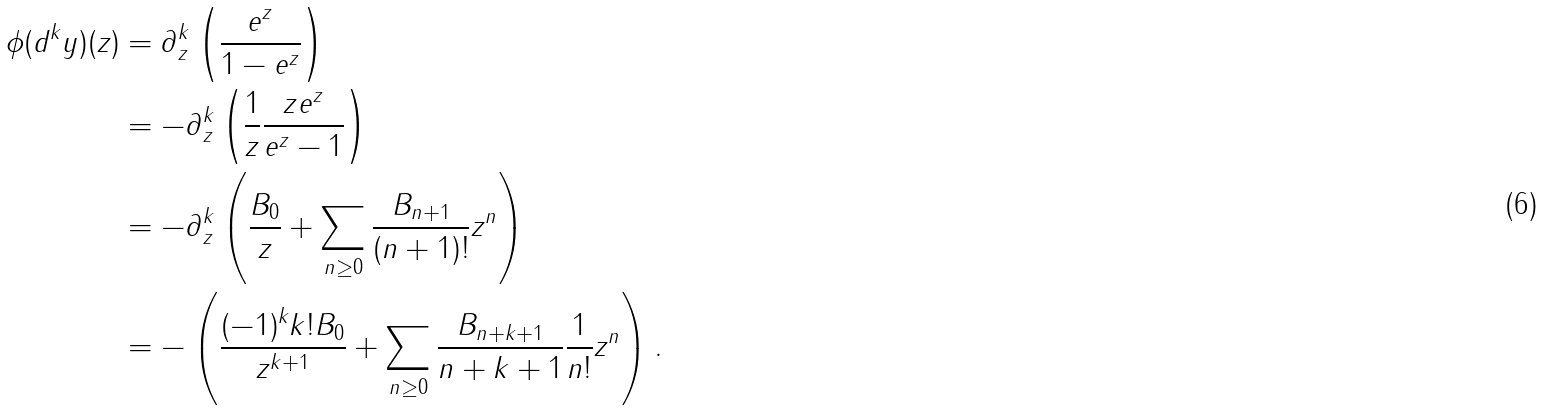<formula> <loc_0><loc_0><loc_500><loc_500>\phi ( d ^ { k } y ) ( z ) & = \partial _ { z } ^ { k } \left ( \frac { e ^ { z } } { 1 - e ^ { z } } \right ) \\ & = - \partial _ { z } ^ { k } \left ( \frac { 1 } { z } \frac { z e ^ { z } } { e ^ { z } - 1 } \right ) \\ & = - \partial _ { z } ^ { k } \left ( \frac { B _ { 0 } } { z } + \sum _ { n \geq 0 } \frac { B _ { n + 1 } } { ( n + 1 ) ! } z ^ { n } \right ) \\ & = - \left ( \frac { ( - 1 ) ^ { k } k ! B _ { 0 } } { z ^ { k + 1 } } + \sum _ { n \geq 0 } \frac { B _ { n + k + 1 } } { n + k + 1 } \frac { 1 } { n ! } z ^ { n } \right ) .</formula> 